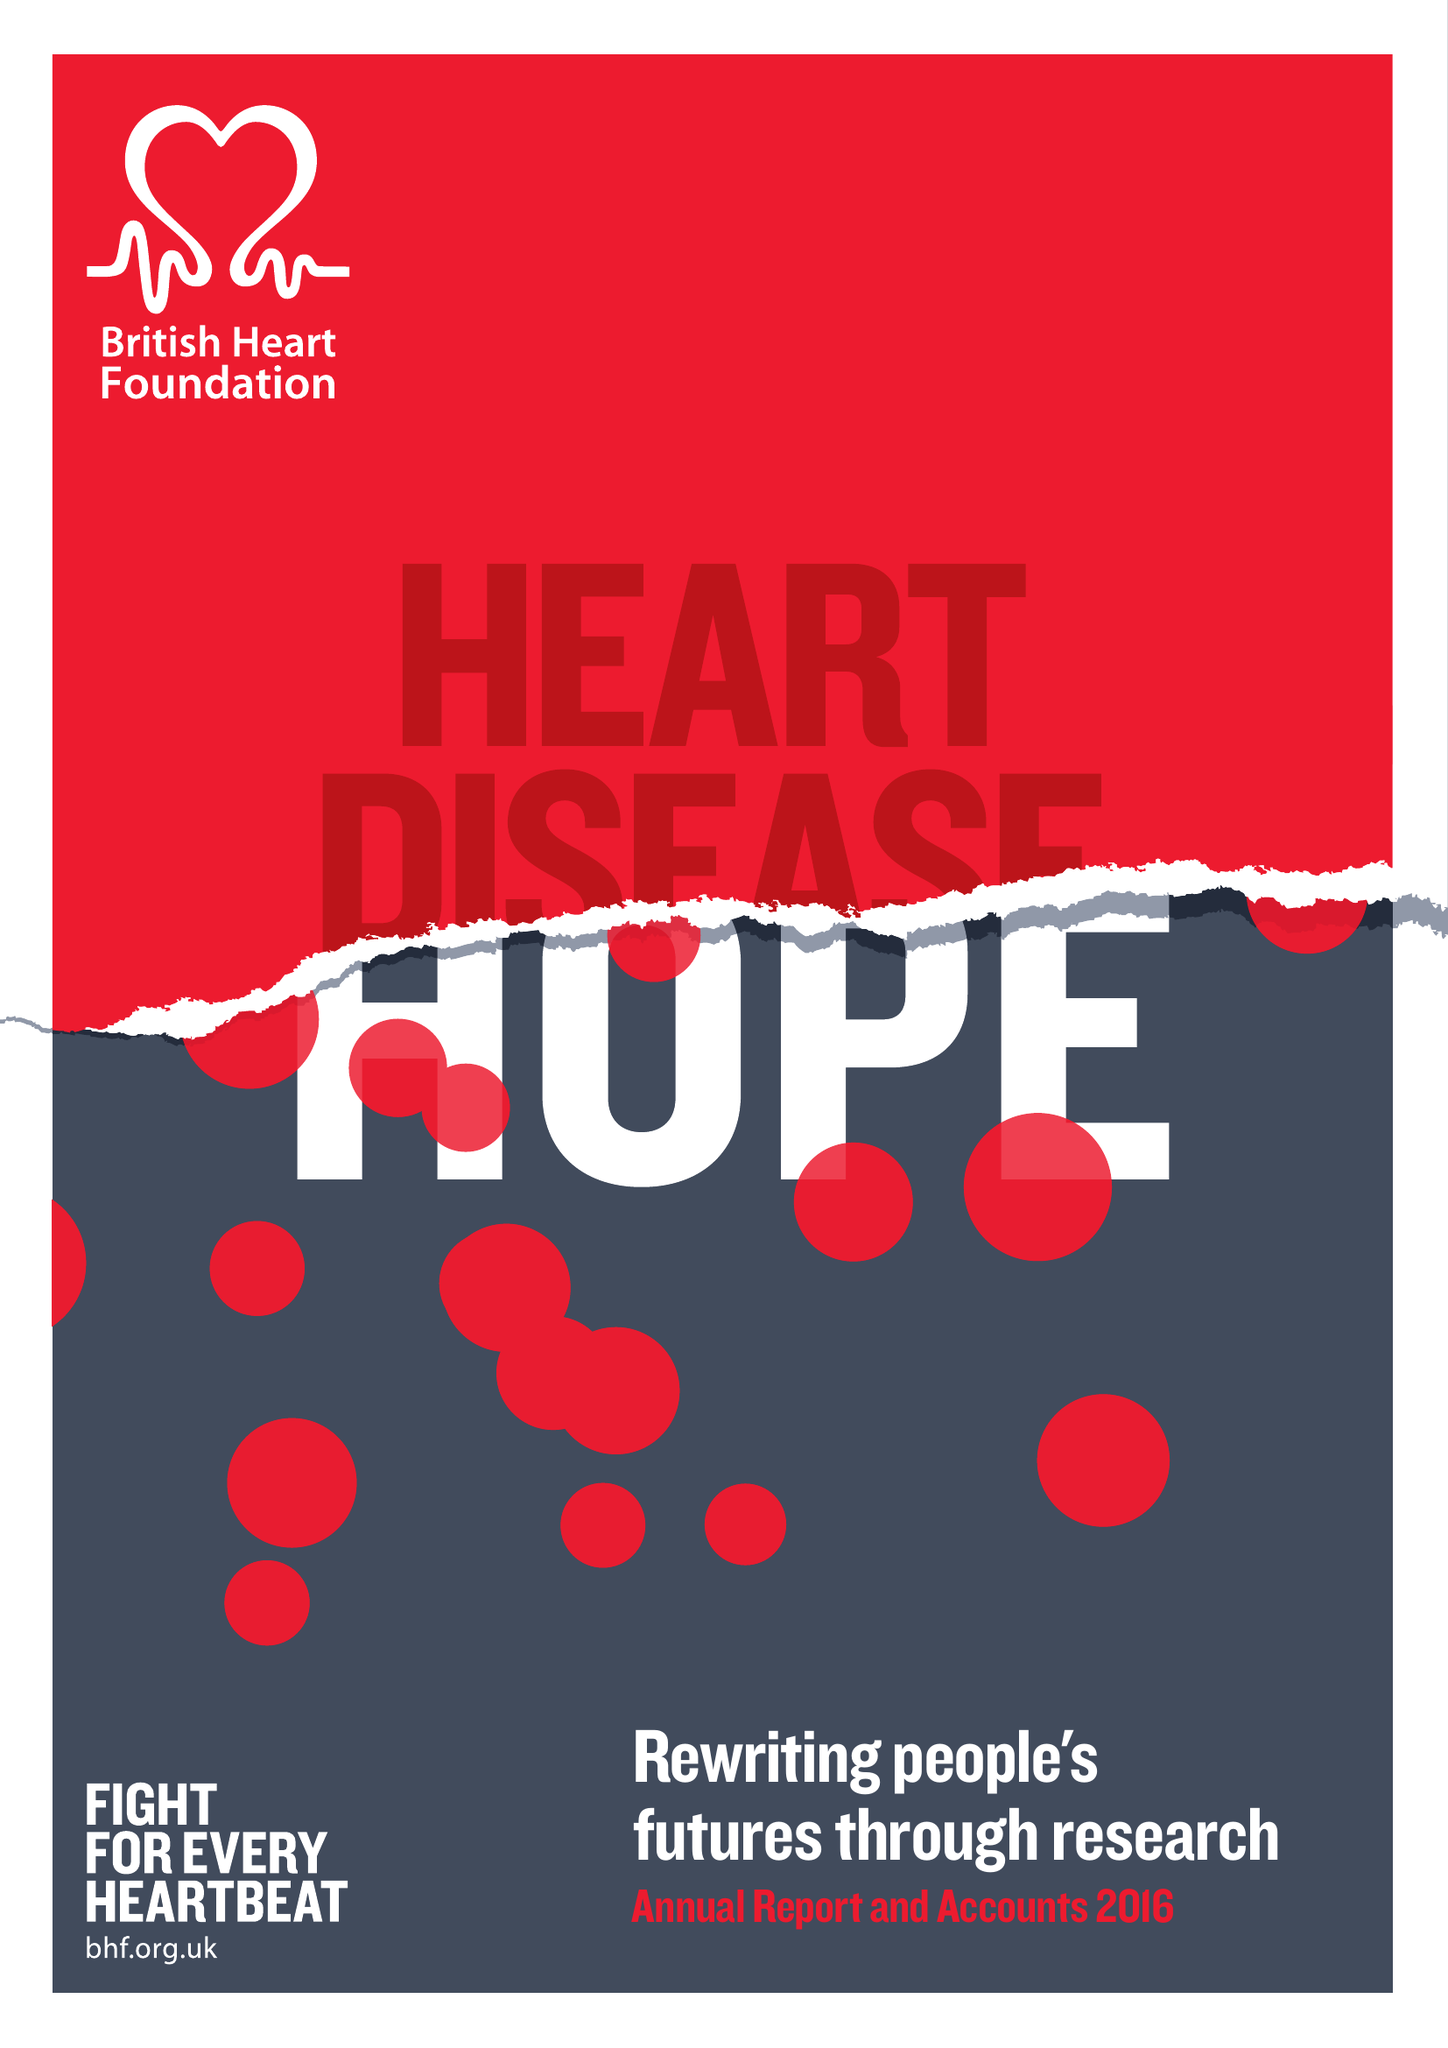What is the value for the charity_name?
Answer the question using a single word or phrase. British Heart Foundation 